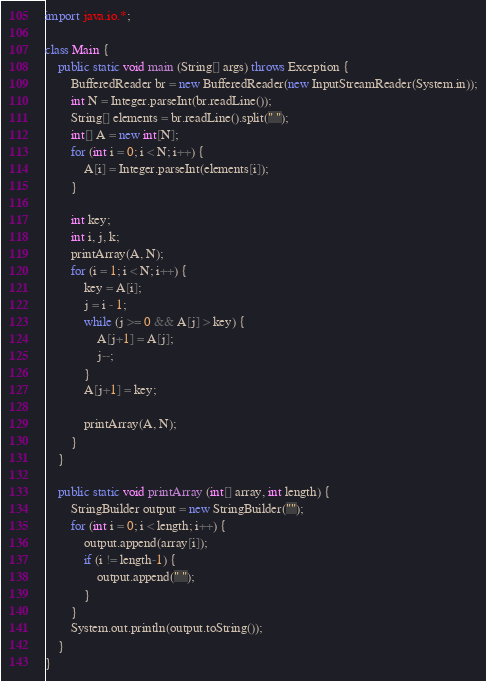Convert code to text. <code><loc_0><loc_0><loc_500><loc_500><_Java_>import java.io.*;

class Main {
    public static void main (String[] args) throws Exception {
        BufferedReader br = new BufferedReader(new InputStreamReader(System.in));
        int N = Integer.parseInt(br.readLine());
        String[] elements = br.readLine().split(" ");
        int[] A = new int[N];
        for (int i = 0; i < N; i++) {
            A[i] = Integer.parseInt(elements[i]);
        }

        int key;
        int i, j, k;
        printArray(A, N);
        for (i = 1; i < N; i++) {
            key = A[i];
            j = i - 1;
            while (j >= 0 && A[j] > key) {
                A[j+1] = A[j];
                j--;
            }
            A[j+1] = key;

            printArray(A, N);
        }
    }

    public static void printArray (int[] array, int length) {
        StringBuilder output = new StringBuilder("");
        for (int i = 0; i < length; i++) {
            output.append(array[i]);
            if (i != length-1) {
                output.append(" ");
            }
        }
        System.out.println(output.toString());
    }
}</code> 